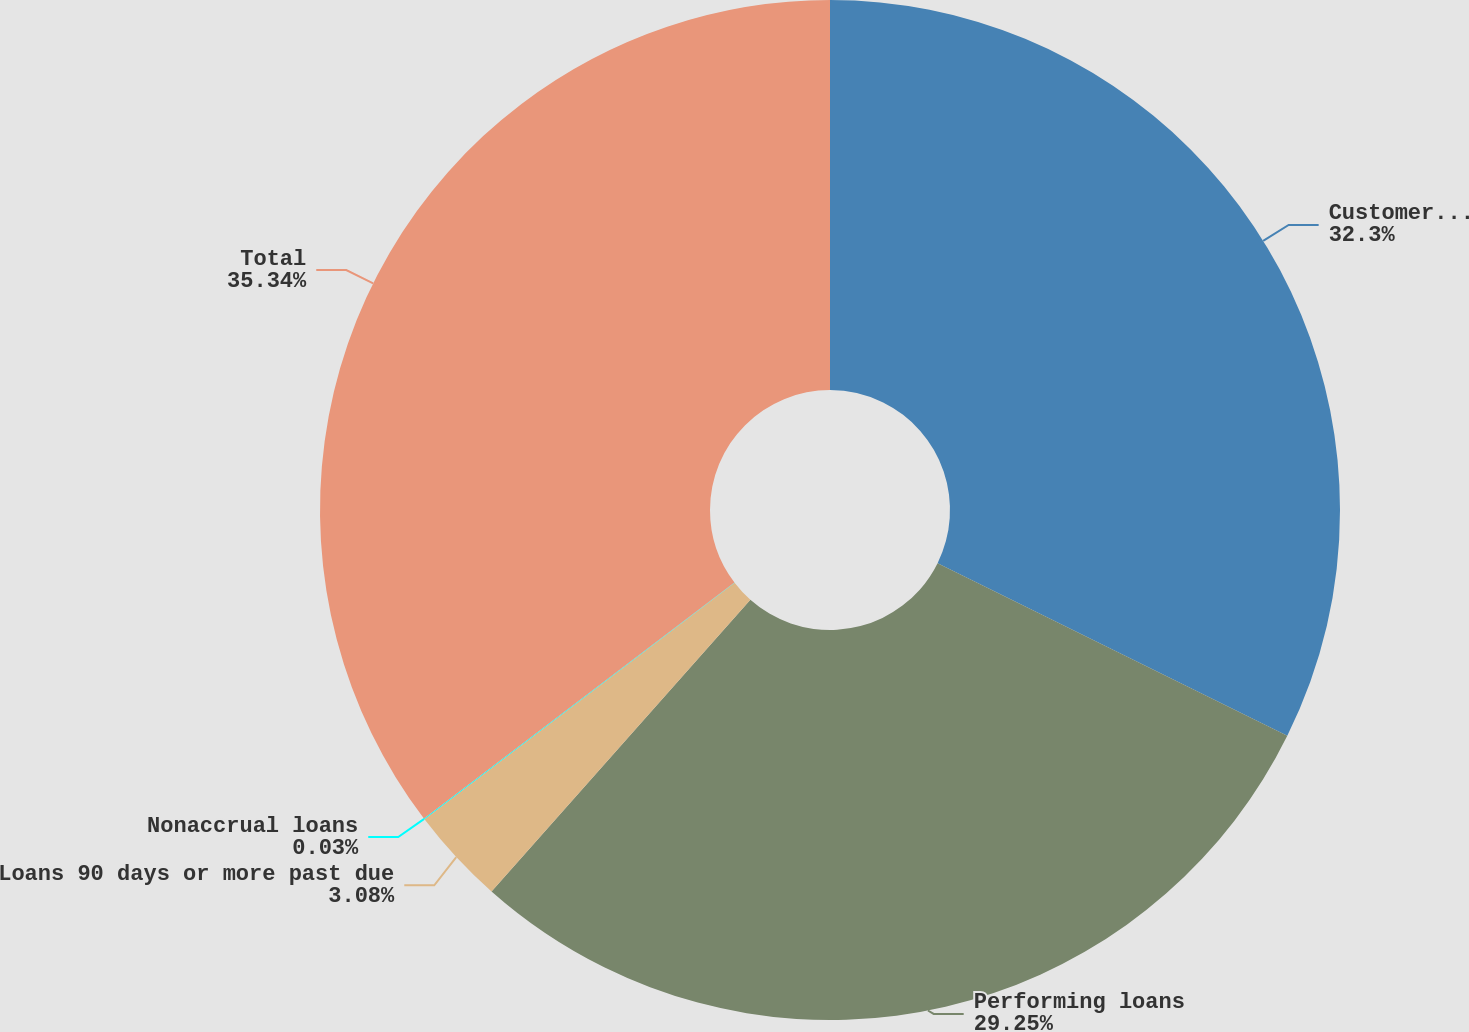Convert chart. <chart><loc_0><loc_0><loc_500><loc_500><pie_chart><fcel>Customer resale agreements<fcel>Performing loans<fcel>Loans 90 days or more past due<fcel>Nonaccrual loans<fcel>Total<nl><fcel>32.3%<fcel>29.25%<fcel>3.08%<fcel>0.03%<fcel>35.34%<nl></chart> 